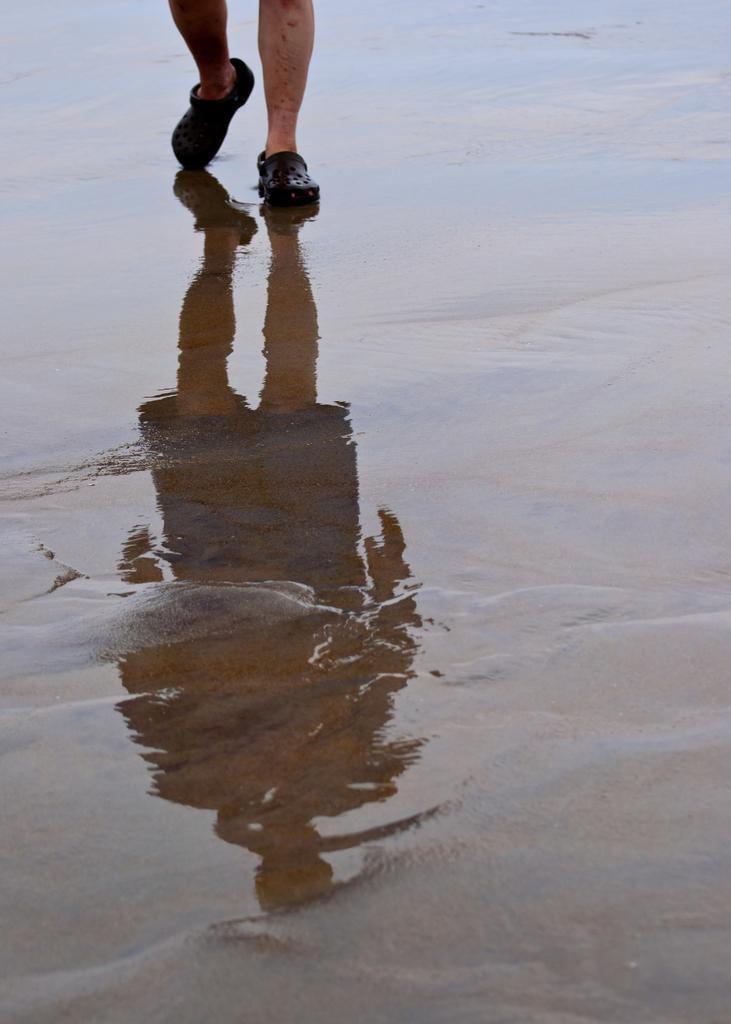What is the main subject of the image? There is a person in the image. What is the person doing in the image? The person is walking on the beach sand. What can be seen in the background of the image? Water is visible in the image. What type of clam can be seen jumping out of the water in the image? There is no clam present in the image, and clams do not jump out of the water. 